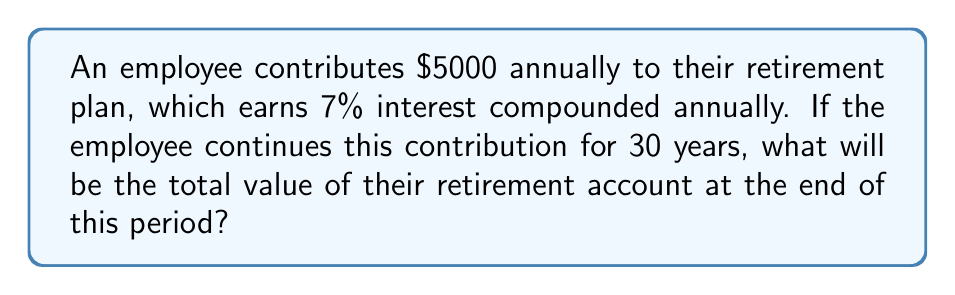Can you solve this math problem? To solve this problem, we'll use the formula for the future value of an annuity with compound interest:

$$A = P \cdot \frac{(1 + r)^n - 1}{r}$$

Where:
$A$ = the future value
$P$ = the annual payment (contribution)
$r$ = the annual interest rate
$n$ = the number of years

Given:
$P = \$5000$
$r = 7\% = 0.07$
$n = 30$ years

Let's substitute these values into the formula:

$$A = 5000 \cdot \frac{(1 + 0.07)^{30} - 1}{0.07}$$

Now, let's calculate step by step:

1) First, calculate $(1 + 0.07)^{30}$:
   $(1.07)^{30} \approx 7.6123$

2) Subtract 1 from this result:
   $7.6123 - 1 = 6.6123$

3) Divide by 0.07:
   $\frac{6.6123}{0.07} \approx 94.4614$

4) Multiply by 5000:
   $5000 \cdot 94.4614 = 472,307$

Therefore, the total value of the retirement account after 30 years will be approximately $472,307.
Answer: $472,307 